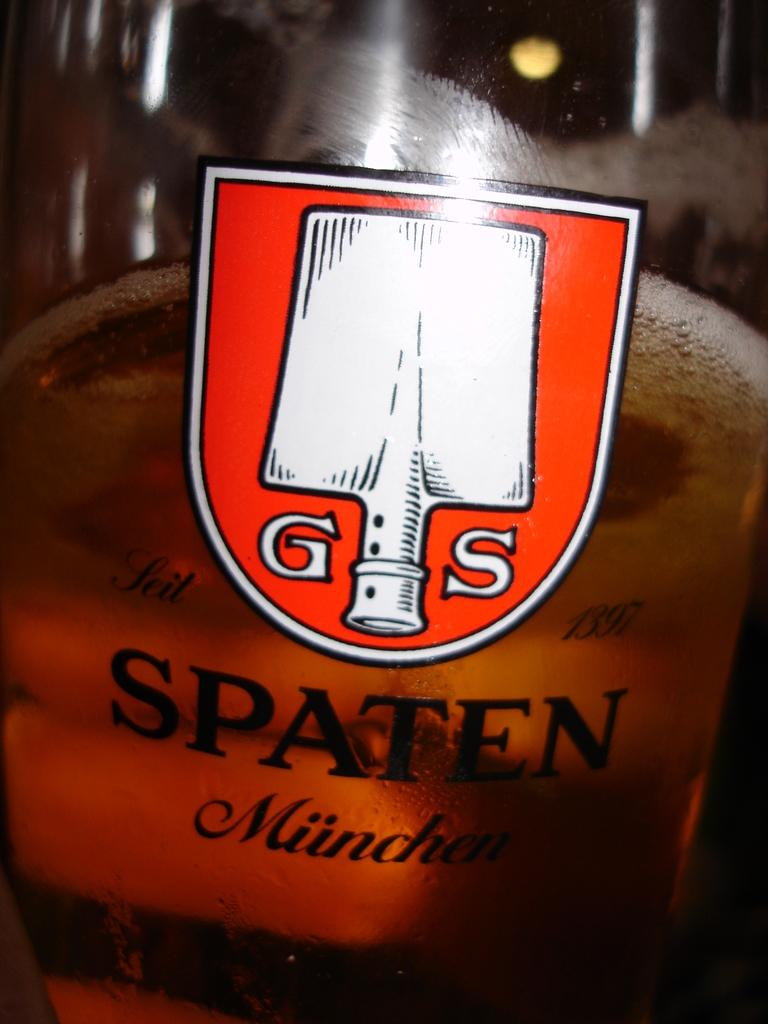<image>
Provide a brief description of the given image. SPATEN glass with partial liquid in a close up 